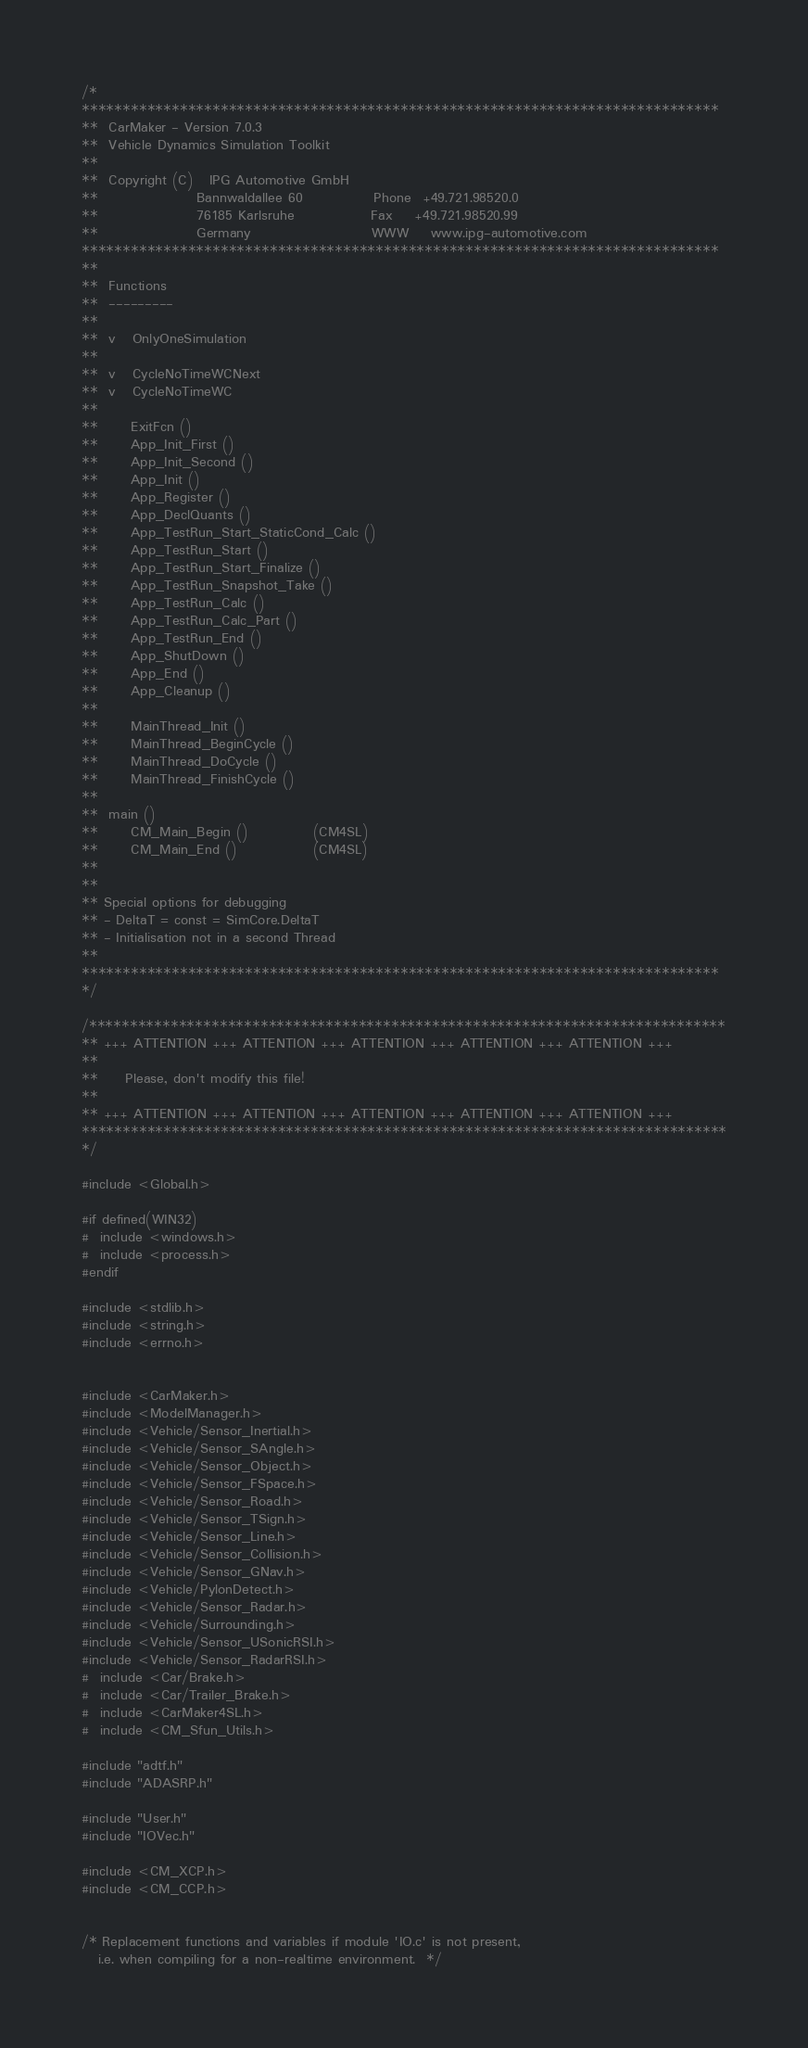<code> <loc_0><loc_0><loc_500><loc_500><_C_>/*
******************************************************************************
**  CarMaker - Version 7.0.3
**  Vehicle Dynamics Simulation Toolkit
**
**  Copyright (C)   IPG Automotive GmbH
**                  Bannwaldallee 60             Phone  +49.721.98520.0
**                  76185 Karlsruhe              Fax    +49.721.98520.99
**                  Germany                      WWW    www.ipg-automotive.com
******************************************************************************
**
**  Functions
**  ---------
**
**	v	OnlyOneSimulation
**
**	v	CycleNoTimeWCNext
**	v	CycleNoTimeWC
**
**		ExitFcn ()
**		App_Init_First ()
**		App_Init_Second ()
**		App_Init ()
**		App_Register ()
**		App_DeclQuants ()
**		App_TestRun_Start_StaticCond_Calc ()
**		App_TestRun_Start ()
**		App_TestRun_Start_Finalize ()
**		App_TestRun_Snapshot_Take ()
**		App_TestRun_Calc ()
**		App_TestRun_Calc_Part ()
**		App_TestRun_End ()
**		App_ShutDown ()
**		App_End ()
**		App_Cleanup ()
**
**		MainThread_Init ()
**		MainThread_BeginCycle ()
**		MainThread_DoCycle ()
**		MainThread_FinishCycle ()
**
**	main ()
**		CM_Main_Begin ()			(CM4SL)
**		CM_Main_End ()				(CM4SL)
**
**
** Special options for debugging
** - DeltaT = const = SimCore.DeltaT
** - Initialisation not in a second Thread
**
******************************************************************************
*/

/******************************************************************************
** +++ ATTENTION +++ ATTENTION +++ ATTENTION +++ ATTENTION +++ ATTENTION +++
**
**     Please, don't modify this file!
**
** +++ ATTENTION +++ ATTENTION +++ ATTENTION +++ ATTENTION +++ ATTENTION +++
*******************************************************************************
*/

#include <Global.h>

#if defined(WIN32)
#  include <windows.h>
#  include <process.h>
#endif

#include <stdlib.h>
#include <string.h>
#include <errno.h>


#include <CarMaker.h>
#include <ModelManager.h>
#include <Vehicle/Sensor_Inertial.h>
#include <Vehicle/Sensor_SAngle.h>
#include <Vehicle/Sensor_Object.h>
#include <Vehicle/Sensor_FSpace.h>
#include <Vehicle/Sensor_Road.h>
#include <Vehicle/Sensor_TSign.h>
#include <Vehicle/Sensor_Line.h>
#include <Vehicle/Sensor_Collision.h>
#include <Vehicle/Sensor_GNav.h>
#include <Vehicle/PylonDetect.h>
#include <Vehicle/Sensor_Radar.h>
#include <Vehicle/Surrounding.h>
#include <Vehicle/Sensor_USonicRSI.h>
#include <Vehicle/Sensor_RadarRSI.h>
#  include <Car/Brake.h>
#  include <Car/Trailer_Brake.h>
#  include <CarMaker4SL.h>
#  include <CM_Sfun_Utils.h>

#include "adtf.h"
#include "ADASRP.h"

#include "User.h"
#include "IOVec.h"

#include <CM_XCP.h>
#include <CM_CCP.h>


/* Replacement functions and variables if module 'IO.c' is not present,
   i.e. when compiling for a non-realtime environment.  */</code> 